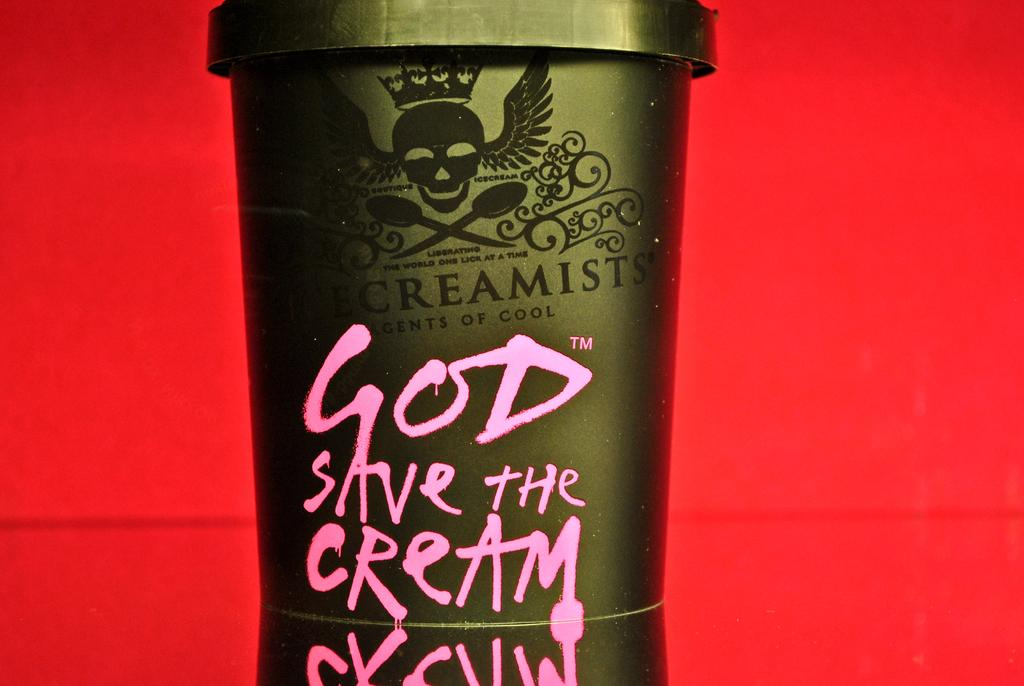<image>
Write a terse but informative summary of the picture. A gold tub of ice cream named "God Save the Cream" sits against a red background. 